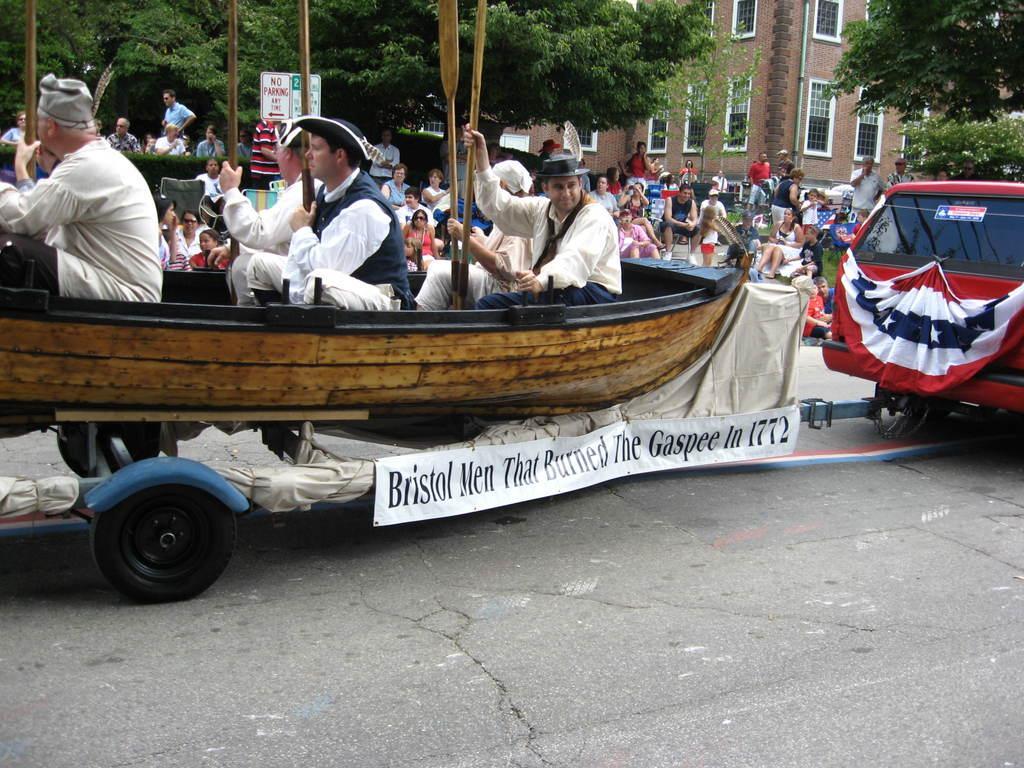Describe this image in one or two sentences. In this picture we can see a group of people holding paddles and sitting in a boat and it looks like the boat is on the cart. Behind the boat, there are boards, people, trees and a building. On the right side of the image, there is a vehicle with a cloth. The cart is attached to the vehicle. 